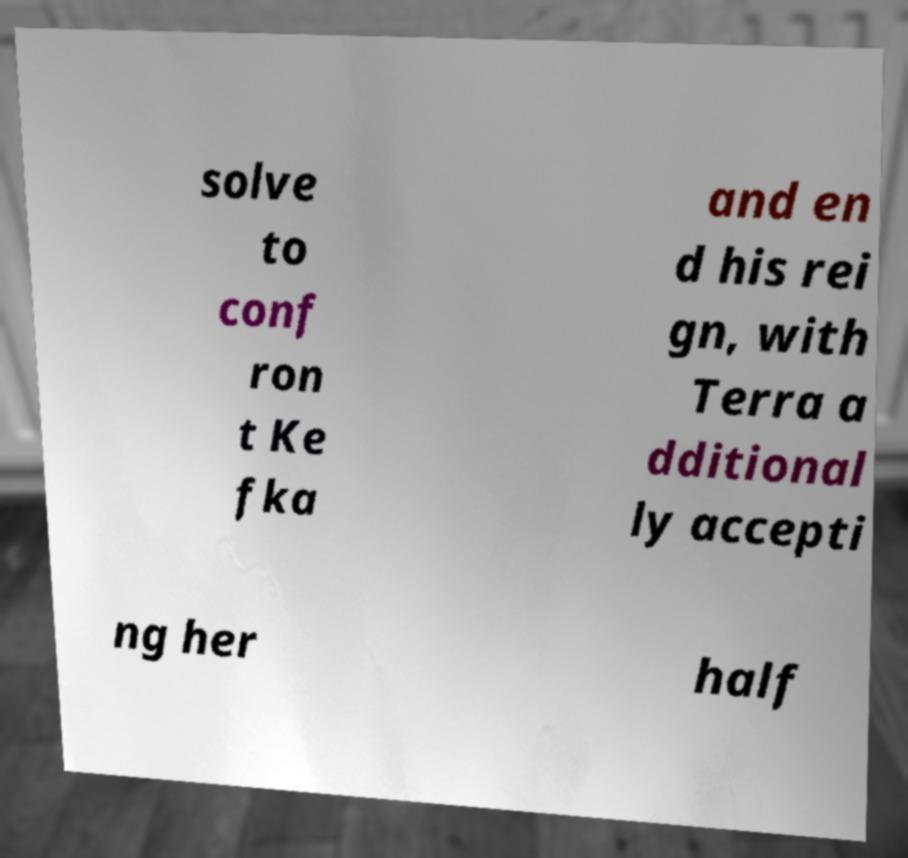Please identify and transcribe the text found in this image. solve to conf ron t Ke fka and en d his rei gn, with Terra a dditional ly accepti ng her half 